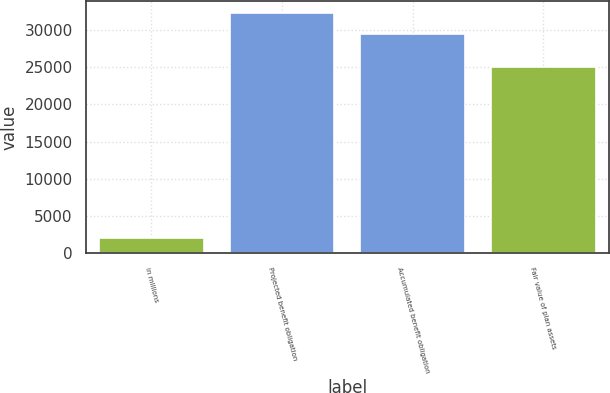Convert chart to OTSL. <chart><loc_0><loc_0><loc_500><loc_500><bar_chart><fcel>in millions<fcel>Projected benefit obligation<fcel>Accumulated benefit obligation<fcel>Fair value of plan assets<nl><fcel>2017<fcel>32232.7<fcel>29454<fcel>24981<nl></chart> 